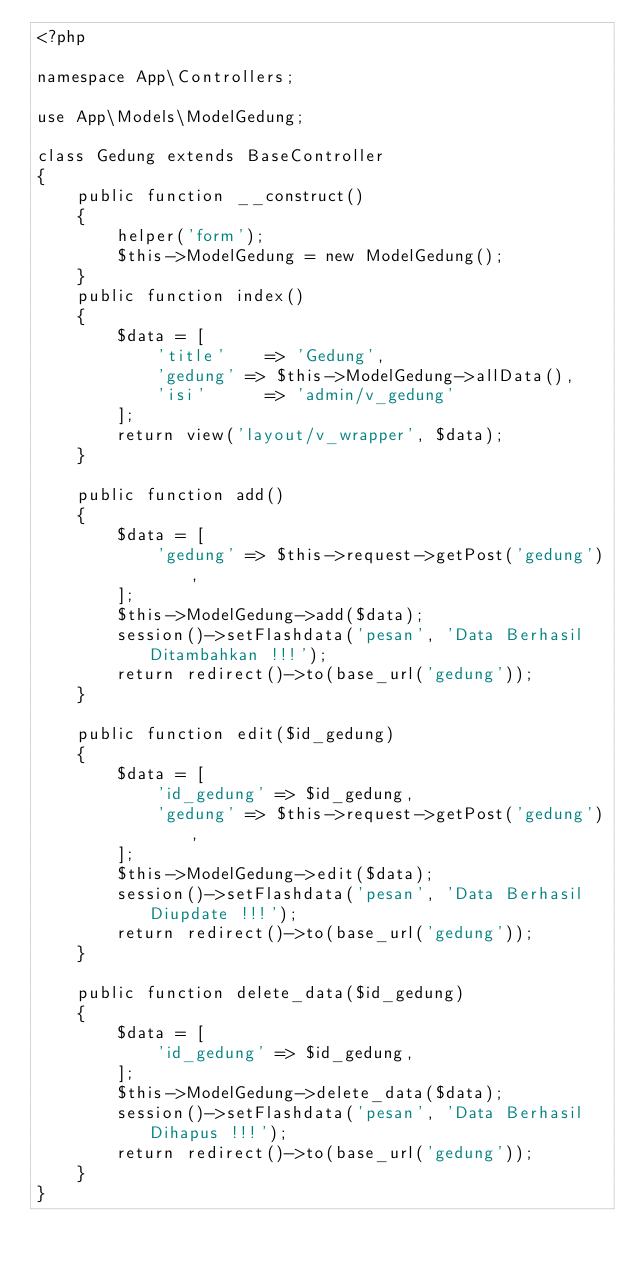<code> <loc_0><loc_0><loc_500><loc_500><_PHP_><?php

namespace App\Controllers;

use App\Models\ModelGedung;

class Gedung extends BaseController
{
    public function __construct()
    {
        helper('form');
        $this->ModelGedung = new ModelGedung();
    }
    public function index()
    {
        $data = [
            'title'    => 'Gedung',
            'gedung' => $this->ModelGedung->allData(),
            'isi'      => 'admin/v_gedung'
        ];
        return view('layout/v_wrapper', $data);
    }

    public function add()
    {
        $data = [
            'gedung' => $this->request->getPost('gedung'),
        ];
        $this->ModelGedung->add($data);
        session()->setFlashdata('pesan', 'Data Berhasil Ditambahkan !!!');
        return redirect()->to(base_url('gedung'));
    }

    public function edit($id_gedung)
    {
        $data = [
            'id_gedung' => $id_gedung,
            'gedung' => $this->request->getPost('gedung'),
        ];
        $this->ModelGedung->edit($data);
        session()->setFlashdata('pesan', 'Data Berhasil Diupdate !!!');
        return redirect()->to(base_url('gedung'));
    }

    public function delete_data($id_gedung)
    {
        $data = [
            'id_gedung' => $id_gedung,
        ];
        $this->ModelGedung->delete_data($data);
        session()->setFlashdata('pesan', 'Data Berhasil Dihapus !!!');
        return redirect()->to(base_url('gedung'));
    }
}
</code> 